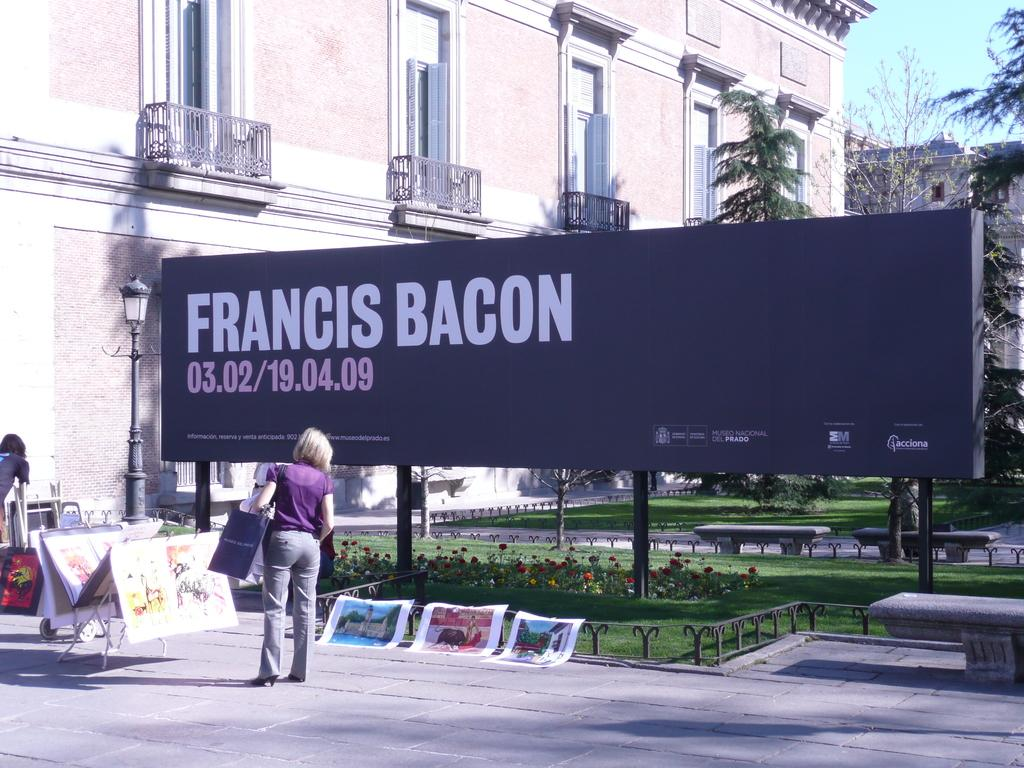<image>
Render a clear and concise summary of the photo. A billboard promoting Francis Bacon has some artwork displayed around it, with a woman looking at some paintings. 